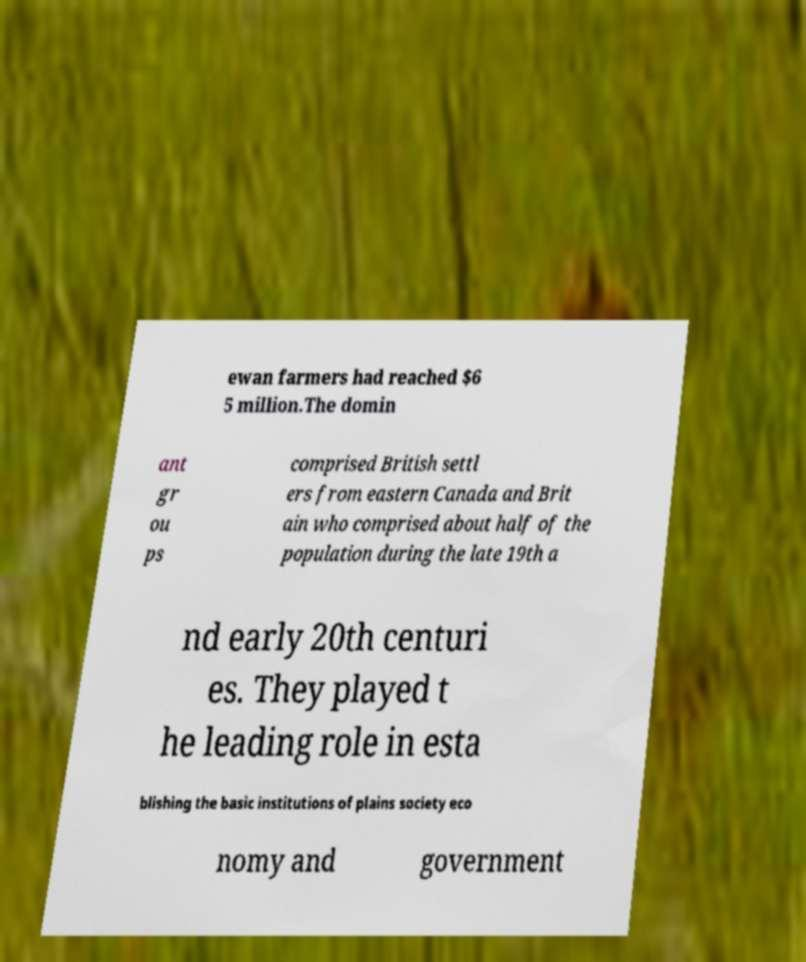Can you read and provide the text displayed in the image?This photo seems to have some interesting text. Can you extract and type it out for me? ewan farmers had reached $6 5 million.The domin ant gr ou ps comprised British settl ers from eastern Canada and Brit ain who comprised about half of the population during the late 19th a nd early 20th centuri es. They played t he leading role in esta blishing the basic institutions of plains society eco nomy and government 